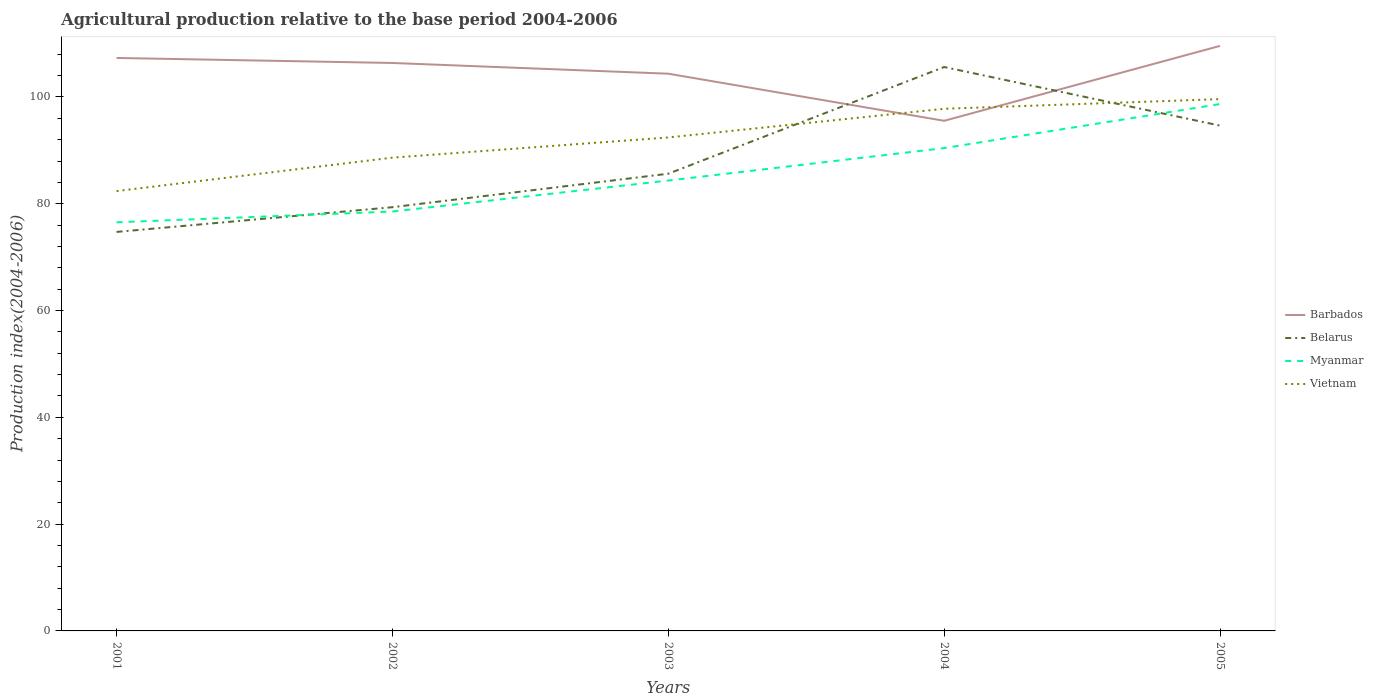How many different coloured lines are there?
Provide a short and direct response. 4. Is the number of lines equal to the number of legend labels?
Offer a terse response. Yes. Across all years, what is the maximum agricultural production index in Belarus?
Your answer should be very brief. 74.72. In which year was the agricultural production index in Barbados maximum?
Your answer should be compact. 2004. What is the total agricultural production index in Barbados in the graph?
Provide a short and direct response. 2.95. What is the difference between the highest and the second highest agricultural production index in Vietnam?
Keep it short and to the point. 17.22. What is the difference between the highest and the lowest agricultural production index in Vietnam?
Keep it short and to the point. 3. Is the agricultural production index in Myanmar strictly greater than the agricultural production index in Vietnam over the years?
Your answer should be very brief. Yes. Are the values on the major ticks of Y-axis written in scientific E-notation?
Your answer should be compact. No. Does the graph contain any zero values?
Offer a very short reply. No. Does the graph contain grids?
Provide a short and direct response. No. Where does the legend appear in the graph?
Make the answer very short. Center right. How many legend labels are there?
Your answer should be very brief. 4. How are the legend labels stacked?
Keep it short and to the point. Vertical. What is the title of the graph?
Offer a very short reply. Agricultural production relative to the base period 2004-2006. What is the label or title of the X-axis?
Ensure brevity in your answer.  Years. What is the label or title of the Y-axis?
Offer a very short reply. Production index(2004-2006). What is the Production index(2004-2006) of Barbados in 2001?
Offer a terse response. 107.3. What is the Production index(2004-2006) of Belarus in 2001?
Your answer should be very brief. 74.72. What is the Production index(2004-2006) of Myanmar in 2001?
Your answer should be compact. 76.52. What is the Production index(2004-2006) in Vietnam in 2001?
Keep it short and to the point. 82.37. What is the Production index(2004-2006) of Barbados in 2002?
Give a very brief answer. 106.36. What is the Production index(2004-2006) in Belarus in 2002?
Make the answer very short. 79.35. What is the Production index(2004-2006) in Myanmar in 2002?
Give a very brief answer. 78.54. What is the Production index(2004-2006) of Vietnam in 2002?
Offer a terse response. 88.63. What is the Production index(2004-2006) of Barbados in 2003?
Your answer should be compact. 104.35. What is the Production index(2004-2006) in Belarus in 2003?
Make the answer very short. 85.62. What is the Production index(2004-2006) of Myanmar in 2003?
Offer a terse response. 84.34. What is the Production index(2004-2006) in Vietnam in 2003?
Provide a short and direct response. 92.41. What is the Production index(2004-2006) in Barbados in 2004?
Offer a terse response. 95.53. What is the Production index(2004-2006) of Belarus in 2004?
Offer a terse response. 105.6. What is the Production index(2004-2006) in Myanmar in 2004?
Ensure brevity in your answer.  90.42. What is the Production index(2004-2006) in Vietnam in 2004?
Your response must be concise. 97.78. What is the Production index(2004-2006) in Barbados in 2005?
Keep it short and to the point. 109.56. What is the Production index(2004-2006) in Belarus in 2005?
Ensure brevity in your answer.  94.63. What is the Production index(2004-2006) of Myanmar in 2005?
Your response must be concise. 98.67. What is the Production index(2004-2006) of Vietnam in 2005?
Provide a succinct answer. 99.59. Across all years, what is the maximum Production index(2004-2006) in Barbados?
Your answer should be compact. 109.56. Across all years, what is the maximum Production index(2004-2006) of Belarus?
Ensure brevity in your answer.  105.6. Across all years, what is the maximum Production index(2004-2006) in Myanmar?
Make the answer very short. 98.67. Across all years, what is the maximum Production index(2004-2006) of Vietnam?
Keep it short and to the point. 99.59. Across all years, what is the minimum Production index(2004-2006) of Barbados?
Provide a succinct answer. 95.53. Across all years, what is the minimum Production index(2004-2006) in Belarus?
Provide a succinct answer. 74.72. Across all years, what is the minimum Production index(2004-2006) in Myanmar?
Offer a terse response. 76.52. Across all years, what is the minimum Production index(2004-2006) of Vietnam?
Offer a terse response. 82.37. What is the total Production index(2004-2006) in Barbados in the graph?
Keep it short and to the point. 523.1. What is the total Production index(2004-2006) in Belarus in the graph?
Your answer should be compact. 439.92. What is the total Production index(2004-2006) of Myanmar in the graph?
Provide a succinct answer. 428.49. What is the total Production index(2004-2006) of Vietnam in the graph?
Your answer should be compact. 460.78. What is the difference between the Production index(2004-2006) in Barbados in 2001 and that in 2002?
Your answer should be compact. 0.94. What is the difference between the Production index(2004-2006) in Belarus in 2001 and that in 2002?
Keep it short and to the point. -4.63. What is the difference between the Production index(2004-2006) of Myanmar in 2001 and that in 2002?
Keep it short and to the point. -2.02. What is the difference between the Production index(2004-2006) of Vietnam in 2001 and that in 2002?
Your answer should be compact. -6.26. What is the difference between the Production index(2004-2006) of Barbados in 2001 and that in 2003?
Your answer should be very brief. 2.95. What is the difference between the Production index(2004-2006) of Belarus in 2001 and that in 2003?
Your response must be concise. -10.9. What is the difference between the Production index(2004-2006) in Myanmar in 2001 and that in 2003?
Keep it short and to the point. -7.82. What is the difference between the Production index(2004-2006) of Vietnam in 2001 and that in 2003?
Give a very brief answer. -10.04. What is the difference between the Production index(2004-2006) of Barbados in 2001 and that in 2004?
Offer a very short reply. 11.77. What is the difference between the Production index(2004-2006) of Belarus in 2001 and that in 2004?
Provide a short and direct response. -30.88. What is the difference between the Production index(2004-2006) of Myanmar in 2001 and that in 2004?
Your answer should be very brief. -13.9. What is the difference between the Production index(2004-2006) in Vietnam in 2001 and that in 2004?
Your answer should be very brief. -15.41. What is the difference between the Production index(2004-2006) of Barbados in 2001 and that in 2005?
Your answer should be compact. -2.26. What is the difference between the Production index(2004-2006) of Belarus in 2001 and that in 2005?
Your answer should be very brief. -19.91. What is the difference between the Production index(2004-2006) of Myanmar in 2001 and that in 2005?
Keep it short and to the point. -22.15. What is the difference between the Production index(2004-2006) of Vietnam in 2001 and that in 2005?
Your response must be concise. -17.22. What is the difference between the Production index(2004-2006) of Barbados in 2002 and that in 2003?
Your answer should be compact. 2.01. What is the difference between the Production index(2004-2006) in Belarus in 2002 and that in 2003?
Your answer should be very brief. -6.27. What is the difference between the Production index(2004-2006) of Myanmar in 2002 and that in 2003?
Provide a succinct answer. -5.8. What is the difference between the Production index(2004-2006) of Vietnam in 2002 and that in 2003?
Offer a terse response. -3.78. What is the difference between the Production index(2004-2006) of Barbados in 2002 and that in 2004?
Make the answer very short. 10.83. What is the difference between the Production index(2004-2006) of Belarus in 2002 and that in 2004?
Offer a very short reply. -26.25. What is the difference between the Production index(2004-2006) in Myanmar in 2002 and that in 2004?
Your answer should be compact. -11.88. What is the difference between the Production index(2004-2006) of Vietnam in 2002 and that in 2004?
Offer a very short reply. -9.15. What is the difference between the Production index(2004-2006) of Belarus in 2002 and that in 2005?
Your answer should be very brief. -15.28. What is the difference between the Production index(2004-2006) of Myanmar in 2002 and that in 2005?
Your response must be concise. -20.13. What is the difference between the Production index(2004-2006) of Vietnam in 2002 and that in 2005?
Offer a terse response. -10.96. What is the difference between the Production index(2004-2006) in Barbados in 2003 and that in 2004?
Your response must be concise. 8.82. What is the difference between the Production index(2004-2006) in Belarus in 2003 and that in 2004?
Your answer should be compact. -19.98. What is the difference between the Production index(2004-2006) of Myanmar in 2003 and that in 2004?
Keep it short and to the point. -6.08. What is the difference between the Production index(2004-2006) of Vietnam in 2003 and that in 2004?
Your answer should be compact. -5.37. What is the difference between the Production index(2004-2006) in Barbados in 2003 and that in 2005?
Offer a terse response. -5.21. What is the difference between the Production index(2004-2006) of Belarus in 2003 and that in 2005?
Your answer should be compact. -9.01. What is the difference between the Production index(2004-2006) of Myanmar in 2003 and that in 2005?
Keep it short and to the point. -14.33. What is the difference between the Production index(2004-2006) in Vietnam in 2003 and that in 2005?
Give a very brief answer. -7.18. What is the difference between the Production index(2004-2006) in Barbados in 2004 and that in 2005?
Keep it short and to the point. -14.03. What is the difference between the Production index(2004-2006) in Belarus in 2004 and that in 2005?
Offer a terse response. 10.97. What is the difference between the Production index(2004-2006) in Myanmar in 2004 and that in 2005?
Provide a short and direct response. -8.25. What is the difference between the Production index(2004-2006) in Vietnam in 2004 and that in 2005?
Your response must be concise. -1.81. What is the difference between the Production index(2004-2006) of Barbados in 2001 and the Production index(2004-2006) of Belarus in 2002?
Keep it short and to the point. 27.95. What is the difference between the Production index(2004-2006) of Barbados in 2001 and the Production index(2004-2006) of Myanmar in 2002?
Keep it short and to the point. 28.76. What is the difference between the Production index(2004-2006) of Barbados in 2001 and the Production index(2004-2006) of Vietnam in 2002?
Make the answer very short. 18.67. What is the difference between the Production index(2004-2006) of Belarus in 2001 and the Production index(2004-2006) of Myanmar in 2002?
Your answer should be compact. -3.82. What is the difference between the Production index(2004-2006) in Belarus in 2001 and the Production index(2004-2006) in Vietnam in 2002?
Offer a terse response. -13.91. What is the difference between the Production index(2004-2006) in Myanmar in 2001 and the Production index(2004-2006) in Vietnam in 2002?
Offer a very short reply. -12.11. What is the difference between the Production index(2004-2006) of Barbados in 2001 and the Production index(2004-2006) of Belarus in 2003?
Provide a succinct answer. 21.68. What is the difference between the Production index(2004-2006) of Barbados in 2001 and the Production index(2004-2006) of Myanmar in 2003?
Give a very brief answer. 22.96. What is the difference between the Production index(2004-2006) in Barbados in 2001 and the Production index(2004-2006) in Vietnam in 2003?
Offer a terse response. 14.89. What is the difference between the Production index(2004-2006) of Belarus in 2001 and the Production index(2004-2006) of Myanmar in 2003?
Provide a succinct answer. -9.62. What is the difference between the Production index(2004-2006) in Belarus in 2001 and the Production index(2004-2006) in Vietnam in 2003?
Provide a short and direct response. -17.69. What is the difference between the Production index(2004-2006) in Myanmar in 2001 and the Production index(2004-2006) in Vietnam in 2003?
Your answer should be compact. -15.89. What is the difference between the Production index(2004-2006) in Barbados in 2001 and the Production index(2004-2006) in Belarus in 2004?
Provide a short and direct response. 1.7. What is the difference between the Production index(2004-2006) of Barbados in 2001 and the Production index(2004-2006) of Myanmar in 2004?
Ensure brevity in your answer.  16.88. What is the difference between the Production index(2004-2006) in Barbados in 2001 and the Production index(2004-2006) in Vietnam in 2004?
Offer a terse response. 9.52. What is the difference between the Production index(2004-2006) in Belarus in 2001 and the Production index(2004-2006) in Myanmar in 2004?
Your answer should be very brief. -15.7. What is the difference between the Production index(2004-2006) of Belarus in 2001 and the Production index(2004-2006) of Vietnam in 2004?
Keep it short and to the point. -23.06. What is the difference between the Production index(2004-2006) in Myanmar in 2001 and the Production index(2004-2006) in Vietnam in 2004?
Provide a succinct answer. -21.26. What is the difference between the Production index(2004-2006) in Barbados in 2001 and the Production index(2004-2006) in Belarus in 2005?
Offer a terse response. 12.67. What is the difference between the Production index(2004-2006) in Barbados in 2001 and the Production index(2004-2006) in Myanmar in 2005?
Provide a succinct answer. 8.63. What is the difference between the Production index(2004-2006) of Barbados in 2001 and the Production index(2004-2006) of Vietnam in 2005?
Keep it short and to the point. 7.71. What is the difference between the Production index(2004-2006) in Belarus in 2001 and the Production index(2004-2006) in Myanmar in 2005?
Offer a terse response. -23.95. What is the difference between the Production index(2004-2006) in Belarus in 2001 and the Production index(2004-2006) in Vietnam in 2005?
Provide a succinct answer. -24.87. What is the difference between the Production index(2004-2006) of Myanmar in 2001 and the Production index(2004-2006) of Vietnam in 2005?
Provide a succinct answer. -23.07. What is the difference between the Production index(2004-2006) in Barbados in 2002 and the Production index(2004-2006) in Belarus in 2003?
Your answer should be very brief. 20.74. What is the difference between the Production index(2004-2006) of Barbados in 2002 and the Production index(2004-2006) of Myanmar in 2003?
Provide a short and direct response. 22.02. What is the difference between the Production index(2004-2006) of Barbados in 2002 and the Production index(2004-2006) of Vietnam in 2003?
Make the answer very short. 13.95. What is the difference between the Production index(2004-2006) of Belarus in 2002 and the Production index(2004-2006) of Myanmar in 2003?
Your answer should be very brief. -4.99. What is the difference between the Production index(2004-2006) of Belarus in 2002 and the Production index(2004-2006) of Vietnam in 2003?
Ensure brevity in your answer.  -13.06. What is the difference between the Production index(2004-2006) of Myanmar in 2002 and the Production index(2004-2006) of Vietnam in 2003?
Offer a very short reply. -13.87. What is the difference between the Production index(2004-2006) of Barbados in 2002 and the Production index(2004-2006) of Belarus in 2004?
Your response must be concise. 0.76. What is the difference between the Production index(2004-2006) in Barbados in 2002 and the Production index(2004-2006) in Myanmar in 2004?
Your response must be concise. 15.94. What is the difference between the Production index(2004-2006) in Barbados in 2002 and the Production index(2004-2006) in Vietnam in 2004?
Provide a succinct answer. 8.58. What is the difference between the Production index(2004-2006) of Belarus in 2002 and the Production index(2004-2006) of Myanmar in 2004?
Your answer should be very brief. -11.07. What is the difference between the Production index(2004-2006) of Belarus in 2002 and the Production index(2004-2006) of Vietnam in 2004?
Your answer should be compact. -18.43. What is the difference between the Production index(2004-2006) in Myanmar in 2002 and the Production index(2004-2006) in Vietnam in 2004?
Give a very brief answer. -19.24. What is the difference between the Production index(2004-2006) of Barbados in 2002 and the Production index(2004-2006) of Belarus in 2005?
Offer a very short reply. 11.73. What is the difference between the Production index(2004-2006) of Barbados in 2002 and the Production index(2004-2006) of Myanmar in 2005?
Provide a short and direct response. 7.69. What is the difference between the Production index(2004-2006) in Barbados in 2002 and the Production index(2004-2006) in Vietnam in 2005?
Provide a succinct answer. 6.77. What is the difference between the Production index(2004-2006) in Belarus in 2002 and the Production index(2004-2006) in Myanmar in 2005?
Give a very brief answer. -19.32. What is the difference between the Production index(2004-2006) of Belarus in 2002 and the Production index(2004-2006) of Vietnam in 2005?
Ensure brevity in your answer.  -20.24. What is the difference between the Production index(2004-2006) in Myanmar in 2002 and the Production index(2004-2006) in Vietnam in 2005?
Your answer should be compact. -21.05. What is the difference between the Production index(2004-2006) in Barbados in 2003 and the Production index(2004-2006) in Belarus in 2004?
Keep it short and to the point. -1.25. What is the difference between the Production index(2004-2006) of Barbados in 2003 and the Production index(2004-2006) of Myanmar in 2004?
Offer a terse response. 13.93. What is the difference between the Production index(2004-2006) in Barbados in 2003 and the Production index(2004-2006) in Vietnam in 2004?
Offer a very short reply. 6.57. What is the difference between the Production index(2004-2006) of Belarus in 2003 and the Production index(2004-2006) of Myanmar in 2004?
Provide a succinct answer. -4.8. What is the difference between the Production index(2004-2006) of Belarus in 2003 and the Production index(2004-2006) of Vietnam in 2004?
Offer a very short reply. -12.16. What is the difference between the Production index(2004-2006) in Myanmar in 2003 and the Production index(2004-2006) in Vietnam in 2004?
Offer a terse response. -13.44. What is the difference between the Production index(2004-2006) of Barbados in 2003 and the Production index(2004-2006) of Belarus in 2005?
Keep it short and to the point. 9.72. What is the difference between the Production index(2004-2006) in Barbados in 2003 and the Production index(2004-2006) in Myanmar in 2005?
Keep it short and to the point. 5.68. What is the difference between the Production index(2004-2006) in Barbados in 2003 and the Production index(2004-2006) in Vietnam in 2005?
Your answer should be very brief. 4.76. What is the difference between the Production index(2004-2006) in Belarus in 2003 and the Production index(2004-2006) in Myanmar in 2005?
Give a very brief answer. -13.05. What is the difference between the Production index(2004-2006) of Belarus in 2003 and the Production index(2004-2006) of Vietnam in 2005?
Your response must be concise. -13.97. What is the difference between the Production index(2004-2006) in Myanmar in 2003 and the Production index(2004-2006) in Vietnam in 2005?
Keep it short and to the point. -15.25. What is the difference between the Production index(2004-2006) in Barbados in 2004 and the Production index(2004-2006) in Belarus in 2005?
Your response must be concise. 0.9. What is the difference between the Production index(2004-2006) of Barbados in 2004 and the Production index(2004-2006) of Myanmar in 2005?
Ensure brevity in your answer.  -3.14. What is the difference between the Production index(2004-2006) of Barbados in 2004 and the Production index(2004-2006) of Vietnam in 2005?
Your answer should be very brief. -4.06. What is the difference between the Production index(2004-2006) of Belarus in 2004 and the Production index(2004-2006) of Myanmar in 2005?
Your answer should be very brief. 6.93. What is the difference between the Production index(2004-2006) in Belarus in 2004 and the Production index(2004-2006) in Vietnam in 2005?
Give a very brief answer. 6.01. What is the difference between the Production index(2004-2006) in Myanmar in 2004 and the Production index(2004-2006) in Vietnam in 2005?
Offer a terse response. -9.17. What is the average Production index(2004-2006) of Barbados per year?
Provide a short and direct response. 104.62. What is the average Production index(2004-2006) of Belarus per year?
Offer a very short reply. 87.98. What is the average Production index(2004-2006) in Myanmar per year?
Your answer should be very brief. 85.7. What is the average Production index(2004-2006) in Vietnam per year?
Give a very brief answer. 92.16. In the year 2001, what is the difference between the Production index(2004-2006) in Barbados and Production index(2004-2006) in Belarus?
Your answer should be very brief. 32.58. In the year 2001, what is the difference between the Production index(2004-2006) of Barbados and Production index(2004-2006) of Myanmar?
Keep it short and to the point. 30.78. In the year 2001, what is the difference between the Production index(2004-2006) of Barbados and Production index(2004-2006) of Vietnam?
Ensure brevity in your answer.  24.93. In the year 2001, what is the difference between the Production index(2004-2006) in Belarus and Production index(2004-2006) in Myanmar?
Your answer should be compact. -1.8. In the year 2001, what is the difference between the Production index(2004-2006) of Belarus and Production index(2004-2006) of Vietnam?
Your response must be concise. -7.65. In the year 2001, what is the difference between the Production index(2004-2006) of Myanmar and Production index(2004-2006) of Vietnam?
Keep it short and to the point. -5.85. In the year 2002, what is the difference between the Production index(2004-2006) in Barbados and Production index(2004-2006) in Belarus?
Your response must be concise. 27.01. In the year 2002, what is the difference between the Production index(2004-2006) of Barbados and Production index(2004-2006) of Myanmar?
Give a very brief answer. 27.82. In the year 2002, what is the difference between the Production index(2004-2006) of Barbados and Production index(2004-2006) of Vietnam?
Offer a terse response. 17.73. In the year 2002, what is the difference between the Production index(2004-2006) of Belarus and Production index(2004-2006) of Myanmar?
Keep it short and to the point. 0.81. In the year 2002, what is the difference between the Production index(2004-2006) of Belarus and Production index(2004-2006) of Vietnam?
Ensure brevity in your answer.  -9.28. In the year 2002, what is the difference between the Production index(2004-2006) in Myanmar and Production index(2004-2006) in Vietnam?
Ensure brevity in your answer.  -10.09. In the year 2003, what is the difference between the Production index(2004-2006) of Barbados and Production index(2004-2006) of Belarus?
Provide a short and direct response. 18.73. In the year 2003, what is the difference between the Production index(2004-2006) in Barbados and Production index(2004-2006) in Myanmar?
Offer a terse response. 20.01. In the year 2003, what is the difference between the Production index(2004-2006) of Barbados and Production index(2004-2006) of Vietnam?
Ensure brevity in your answer.  11.94. In the year 2003, what is the difference between the Production index(2004-2006) in Belarus and Production index(2004-2006) in Myanmar?
Make the answer very short. 1.28. In the year 2003, what is the difference between the Production index(2004-2006) of Belarus and Production index(2004-2006) of Vietnam?
Provide a short and direct response. -6.79. In the year 2003, what is the difference between the Production index(2004-2006) in Myanmar and Production index(2004-2006) in Vietnam?
Provide a short and direct response. -8.07. In the year 2004, what is the difference between the Production index(2004-2006) of Barbados and Production index(2004-2006) of Belarus?
Offer a terse response. -10.07. In the year 2004, what is the difference between the Production index(2004-2006) in Barbados and Production index(2004-2006) in Myanmar?
Offer a very short reply. 5.11. In the year 2004, what is the difference between the Production index(2004-2006) of Barbados and Production index(2004-2006) of Vietnam?
Your response must be concise. -2.25. In the year 2004, what is the difference between the Production index(2004-2006) of Belarus and Production index(2004-2006) of Myanmar?
Make the answer very short. 15.18. In the year 2004, what is the difference between the Production index(2004-2006) in Belarus and Production index(2004-2006) in Vietnam?
Ensure brevity in your answer.  7.82. In the year 2004, what is the difference between the Production index(2004-2006) of Myanmar and Production index(2004-2006) of Vietnam?
Offer a terse response. -7.36. In the year 2005, what is the difference between the Production index(2004-2006) of Barbados and Production index(2004-2006) of Belarus?
Your response must be concise. 14.93. In the year 2005, what is the difference between the Production index(2004-2006) of Barbados and Production index(2004-2006) of Myanmar?
Keep it short and to the point. 10.89. In the year 2005, what is the difference between the Production index(2004-2006) in Barbados and Production index(2004-2006) in Vietnam?
Ensure brevity in your answer.  9.97. In the year 2005, what is the difference between the Production index(2004-2006) of Belarus and Production index(2004-2006) of Myanmar?
Offer a terse response. -4.04. In the year 2005, what is the difference between the Production index(2004-2006) of Belarus and Production index(2004-2006) of Vietnam?
Provide a succinct answer. -4.96. In the year 2005, what is the difference between the Production index(2004-2006) of Myanmar and Production index(2004-2006) of Vietnam?
Your response must be concise. -0.92. What is the ratio of the Production index(2004-2006) of Barbados in 2001 to that in 2002?
Make the answer very short. 1.01. What is the ratio of the Production index(2004-2006) in Belarus in 2001 to that in 2002?
Make the answer very short. 0.94. What is the ratio of the Production index(2004-2006) of Myanmar in 2001 to that in 2002?
Make the answer very short. 0.97. What is the ratio of the Production index(2004-2006) in Vietnam in 2001 to that in 2002?
Provide a short and direct response. 0.93. What is the ratio of the Production index(2004-2006) of Barbados in 2001 to that in 2003?
Make the answer very short. 1.03. What is the ratio of the Production index(2004-2006) of Belarus in 2001 to that in 2003?
Offer a terse response. 0.87. What is the ratio of the Production index(2004-2006) in Myanmar in 2001 to that in 2003?
Keep it short and to the point. 0.91. What is the ratio of the Production index(2004-2006) in Vietnam in 2001 to that in 2003?
Your answer should be compact. 0.89. What is the ratio of the Production index(2004-2006) of Barbados in 2001 to that in 2004?
Offer a terse response. 1.12. What is the ratio of the Production index(2004-2006) of Belarus in 2001 to that in 2004?
Keep it short and to the point. 0.71. What is the ratio of the Production index(2004-2006) of Myanmar in 2001 to that in 2004?
Provide a succinct answer. 0.85. What is the ratio of the Production index(2004-2006) in Vietnam in 2001 to that in 2004?
Keep it short and to the point. 0.84. What is the ratio of the Production index(2004-2006) of Barbados in 2001 to that in 2005?
Offer a terse response. 0.98. What is the ratio of the Production index(2004-2006) in Belarus in 2001 to that in 2005?
Make the answer very short. 0.79. What is the ratio of the Production index(2004-2006) of Myanmar in 2001 to that in 2005?
Offer a very short reply. 0.78. What is the ratio of the Production index(2004-2006) in Vietnam in 2001 to that in 2005?
Your answer should be compact. 0.83. What is the ratio of the Production index(2004-2006) in Barbados in 2002 to that in 2003?
Offer a very short reply. 1.02. What is the ratio of the Production index(2004-2006) of Belarus in 2002 to that in 2003?
Make the answer very short. 0.93. What is the ratio of the Production index(2004-2006) of Myanmar in 2002 to that in 2003?
Ensure brevity in your answer.  0.93. What is the ratio of the Production index(2004-2006) of Vietnam in 2002 to that in 2003?
Your answer should be very brief. 0.96. What is the ratio of the Production index(2004-2006) in Barbados in 2002 to that in 2004?
Offer a very short reply. 1.11. What is the ratio of the Production index(2004-2006) of Belarus in 2002 to that in 2004?
Your answer should be very brief. 0.75. What is the ratio of the Production index(2004-2006) in Myanmar in 2002 to that in 2004?
Make the answer very short. 0.87. What is the ratio of the Production index(2004-2006) of Vietnam in 2002 to that in 2004?
Provide a succinct answer. 0.91. What is the ratio of the Production index(2004-2006) in Barbados in 2002 to that in 2005?
Your answer should be very brief. 0.97. What is the ratio of the Production index(2004-2006) in Belarus in 2002 to that in 2005?
Provide a succinct answer. 0.84. What is the ratio of the Production index(2004-2006) of Myanmar in 2002 to that in 2005?
Ensure brevity in your answer.  0.8. What is the ratio of the Production index(2004-2006) of Vietnam in 2002 to that in 2005?
Offer a terse response. 0.89. What is the ratio of the Production index(2004-2006) of Barbados in 2003 to that in 2004?
Give a very brief answer. 1.09. What is the ratio of the Production index(2004-2006) of Belarus in 2003 to that in 2004?
Make the answer very short. 0.81. What is the ratio of the Production index(2004-2006) of Myanmar in 2003 to that in 2004?
Your answer should be compact. 0.93. What is the ratio of the Production index(2004-2006) in Vietnam in 2003 to that in 2004?
Your answer should be compact. 0.95. What is the ratio of the Production index(2004-2006) in Belarus in 2003 to that in 2005?
Give a very brief answer. 0.9. What is the ratio of the Production index(2004-2006) in Myanmar in 2003 to that in 2005?
Your answer should be very brief. 0.85. What is the ratio of the Production index(2004-2006) in Vietnam in 2003 to that in 2005?
Your answer should be very brief. 0.93. What is the ratio of the Production index(2004-2006) of Barbados in 2004 to that in 2005?
Offer a very short reply. 0.87. What is the ratio of the Production index(2004-2006) of Belarus in 2004 to that in 2005?
Your answer should be very brief. 1.12. What is the ratio of the Production index(2004-2006) in Myanmar in 2004 to that in 2005?
Offer a terse response. 0.92. What is the ratio of the Production index(2004-2006) in Vietnam in 2004 to that in 2005?
Provide a short and direct response. 0.98. What is the difference between the highest and the second highest Production index(2004-2006) in Barbados?
Your response must be concise. 2.26. What is the difference between the highest and the second highest Production index(2004-2006) in Belarus?
Keep it short and to the point. 10.97. What is the difference between the highest and the second highest Production index(2004-2006) in Myanmar?
Make the answer very short. 8.25. What is the difference between the highest and the second highest Production index(2004-2006) of Vietnam?
Offer a terse response. 1.81. What is the difference between the highest and the lowest Production index(2004-2006) in Barbados?
Provide a succinct answer. 14.03. What is the difference between the highest and the lowest Production index(2004-2006) in Belarus?
Give a very brief answer. 30.88. What is the difference between the highest and the lowest Production index(2004-2006) of Myanmar?
Your response must be concise. 22.15. What is the difference between the highest and the lowest Production index(2004-2006) of Vietnam?
Offer a very short reply. 17.22. 